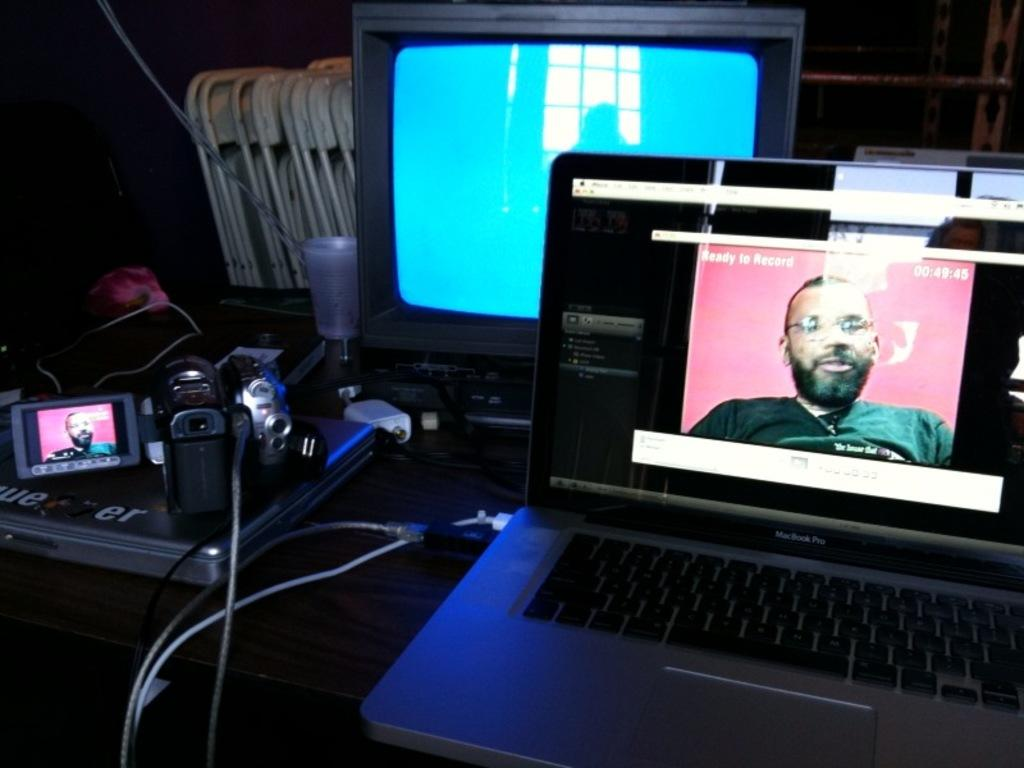<image>
Give a short and clear explanation of the subsequent image. a macbook pro on the desk with an open window on it 